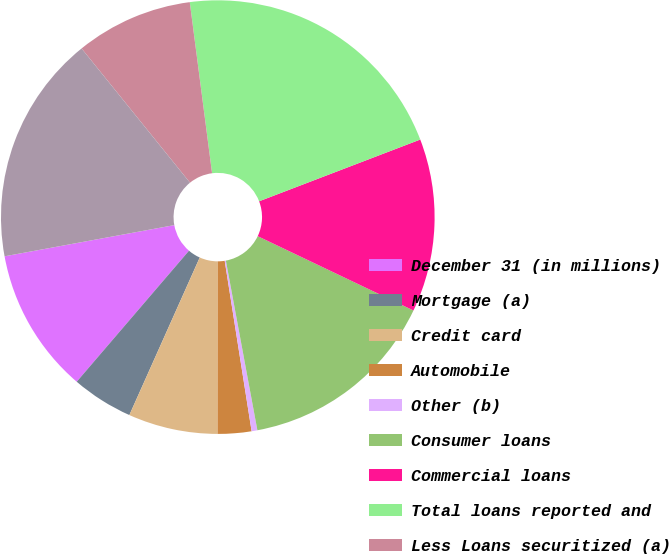<chart> <loc_0><loc_0><loc_500><loc_500><pie_chart><fcel>December 31 (in millions)<fcel>Mortgage (a)<fcel>Credit card<fcel>Automobile<fcel>Other (b)<fcel>Consumer loans<fcel>Commercial loans<fcel>Total loans reported and<fcel>Less Loans securitized (a)<fcel>Reported<nl><fcel>10.83%<fcel>4.59%<fcel>6.67%<fcel>2.51%<fcel>0.43%<fcel>14.99%<fcel>12.91%<fcel>21.24%<fcel>8.75%<fcel>17.08%<nl></chart> 